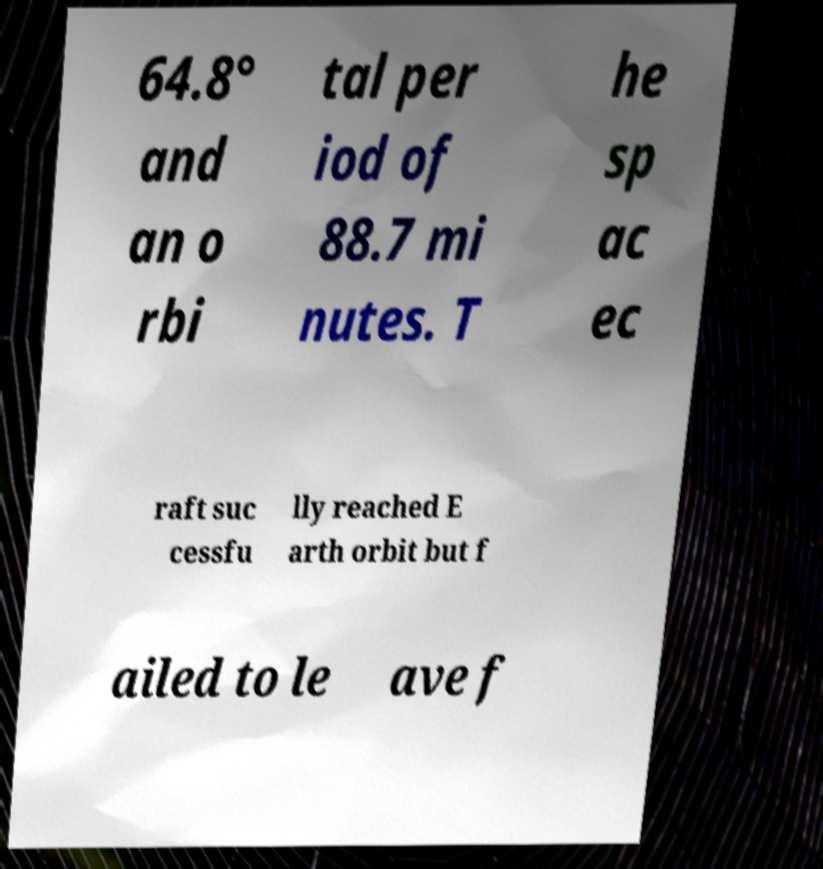Please read and relay the text visible in this image. What does it say? 64.8° and an o rbi tal per iod of 88.7 mi nutes. T he sp ac ec raft suc cessfu lly reached E arth orbit but f ailed to le ave f 